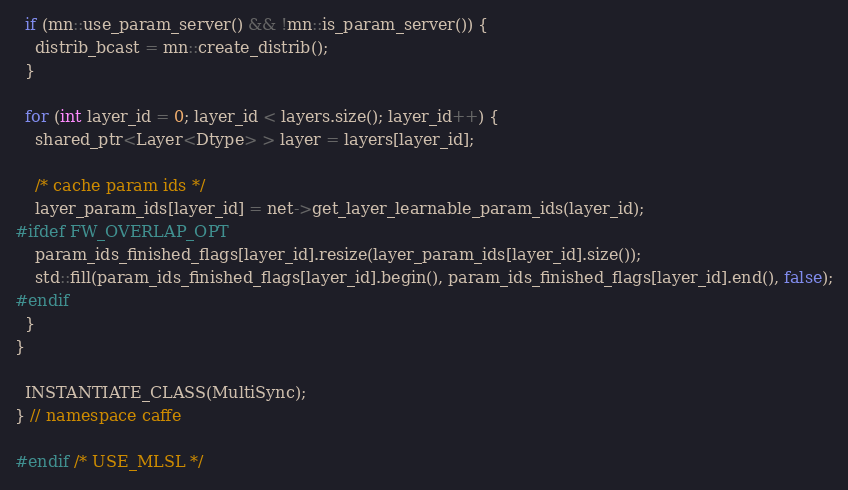Convert code to text. <code><loc_0><loc_0><loc_500><loc_500><_C++_>  if (mn::use_param_server() && !mn::is_param_server()) {
    distrib_bcast = mn::create_distrib();
  }

  for (int layer_id = 0; layer_id < layers.size(); layer_id++) {
    shared_ptr<Layer<Dtype> > layer = layers[layer_id];

    /* cache param ids */
    layer_param_ids[layer_id] = net->get_layer_learnable_param_ids(layer_id);
#ifdef FW_OVERLAP_OPT
    param_ids_finished_flags[layer_id].resize(layer_param_ids[layer_id].size());
    std::fill(param_ids_finished_flags[layer_id].begin(), param_ids_finished_flags[layer_id].end(), false);
#endif
  }
}

  INSTANTIATE_CLASS(MultiSync);
} // namespace caffe

#endif /* USE_MLSL */
</code> 